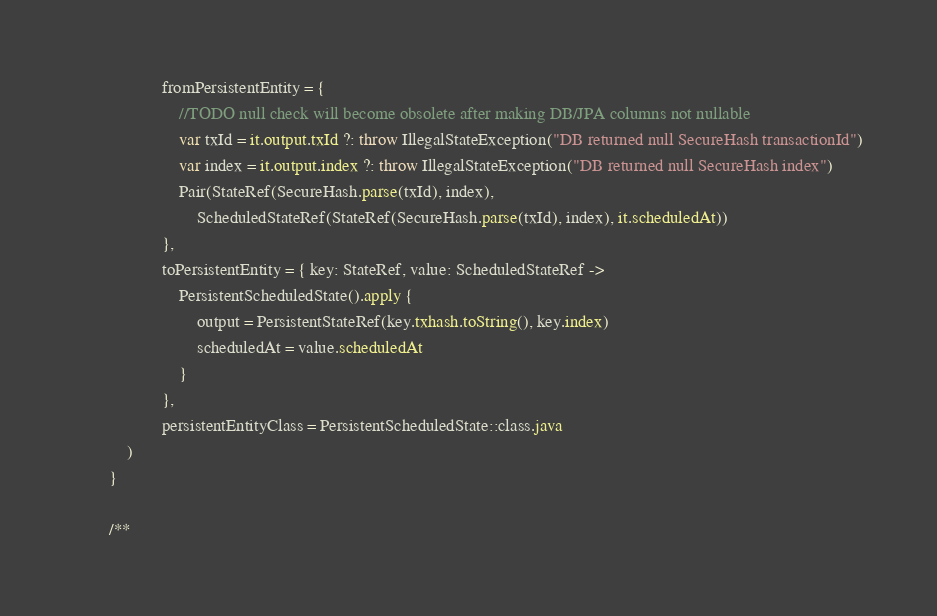<code> <loc_0><loc_0><loc_500><loc_500><_Kotlin_>                    fromPersistentEntity = {
                        //TODO null check will become obsolete after making DB/JPA columns not nullable
                        var txId = it.output.txId ?: throw IllegalStateException("DB returned null SecureHash transactionId")
                        var index = it.output.index ?: throw IllegalStateException("DB returned null SecureHash index")
                        Pair(StateRef(SecureHash.parse(txId), index),
                            ScheduledStateRef(StateRef(SecureHash.parse(txId), index), it.scheduledAt))
                    },
                    toPersistentEntity = { key: StateRef, value: ScheduledStateRef ->
                        PersistentScheduledState().apply {
                            output = PersistentStateRef(key.txhash.toString(), key.index)
                            scheduledAt = value.scheduledAt
                        }
                    },
                    persistentEntityClass = PersistentScheduledState::class.java
            )
        }

        /**</code> 